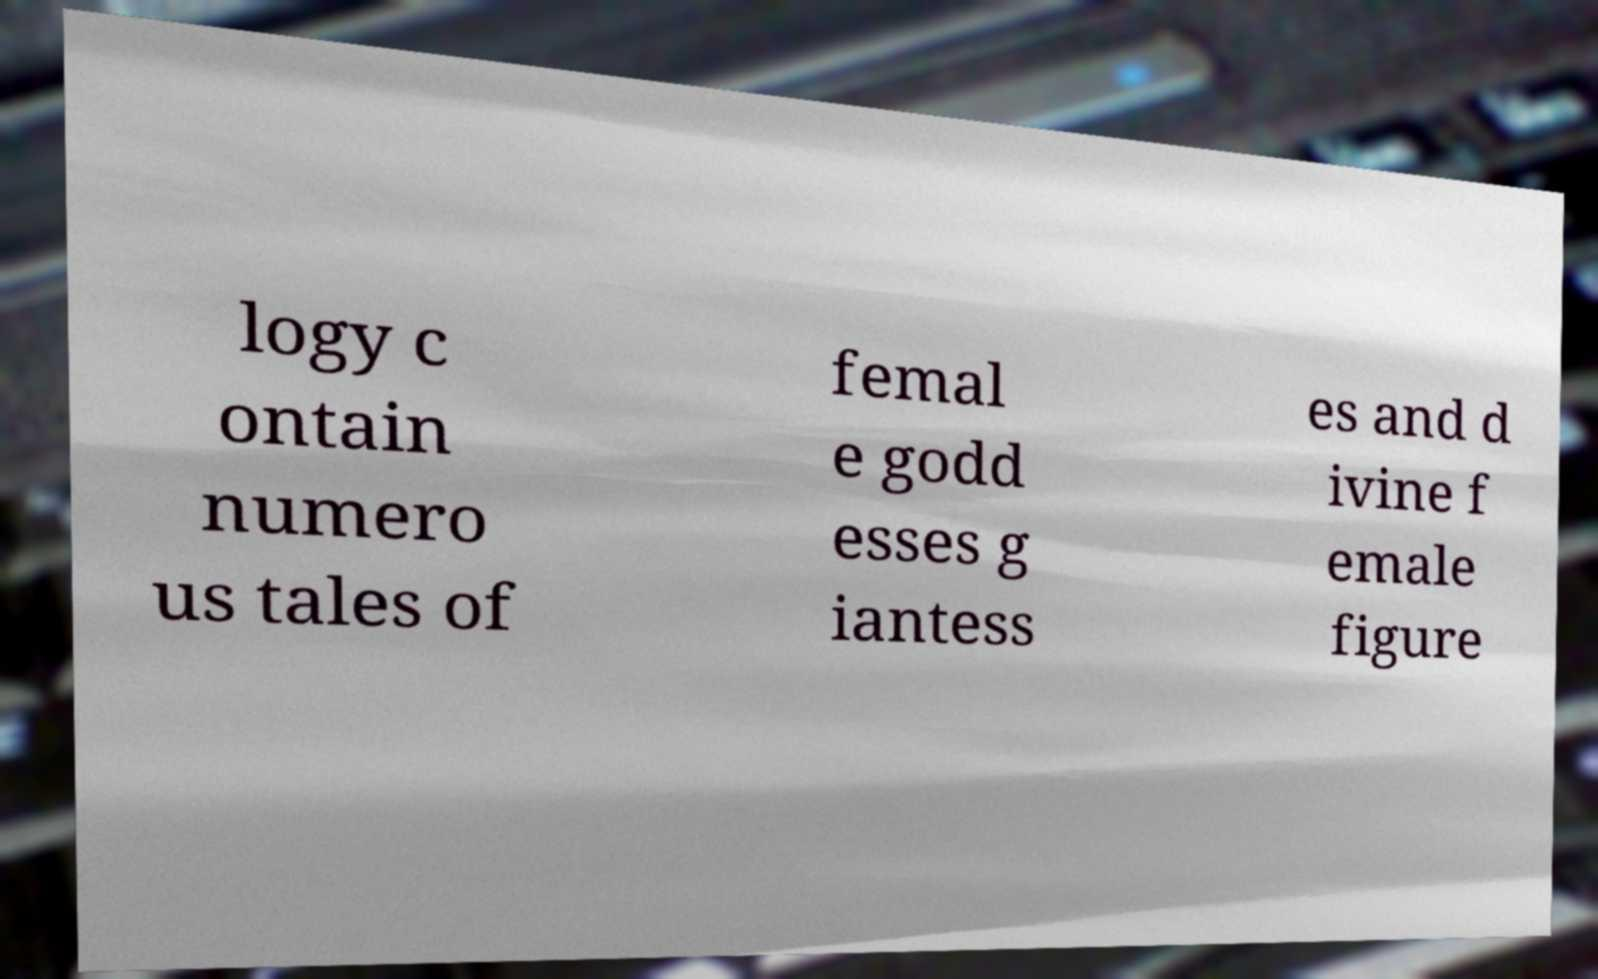For documentation purposes, I need the text within this image transcribed. Could you provide that? logy c ontain numero us tales of femal e godd esses g iantess es and d ivine f emale figure 